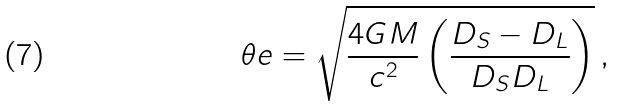Convert formula to latex. <formula><loc_0><loc_0><loc_500><loc_500>\theta e = \sqrt { \frac { 4 G M } { c ^ { 2 } } \left ( \frac { D _ { S } - D _ { L } } { D _ { S } D _ { L } } \right ) } \, ,</formula> 